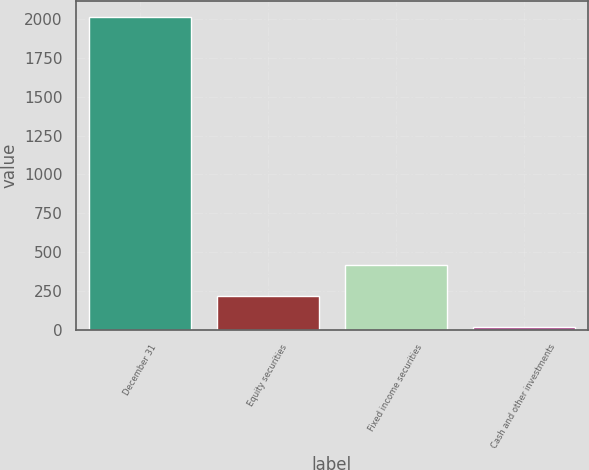Convert chart to OTSL. <chart><loc_0><loc_0><loc_500><loc_500><bar_chart><fcel>December 31<fcel>Equity securities<fcel>Fixed income securities<fcel>Cash and other investments<nl><fcel>2018<fcel>218.9<fcel>418.8<fcel>19<nl></chart> 